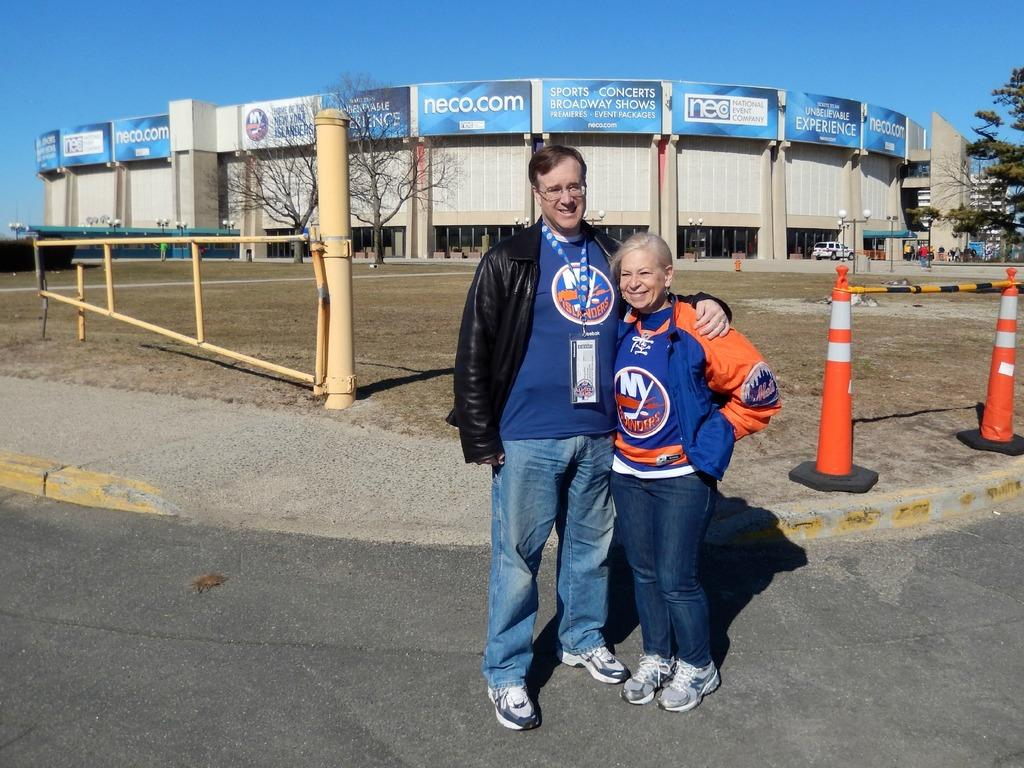Provide a one-sentence caption for the provided image. A man and a woman standing in front of the home Arena of the New York Islanders. 